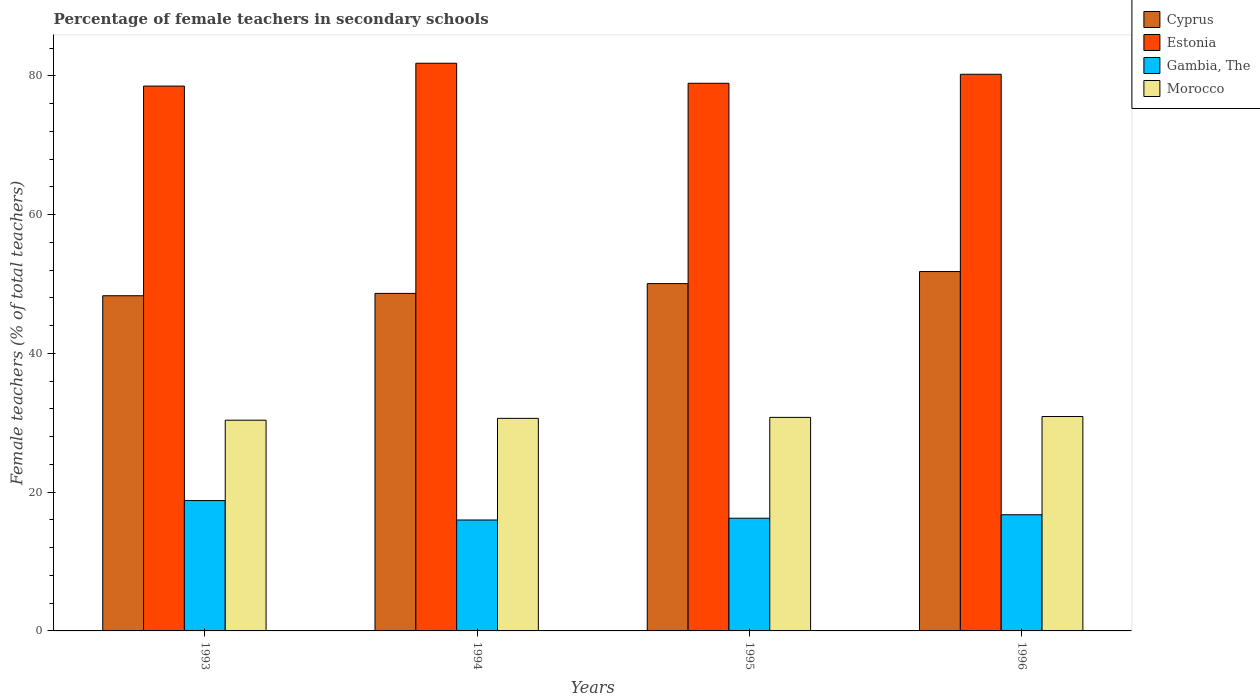How many different coloured bars are there?
Keep it short and to the point. 4. Are the number of bars per tick equal to the number of legend labels?
Your answer should be compact. Yes. Are the number of bars on each tick of the X-axis equal?
Keep it short and to the point. Yes. What is the label of the 4th group of bars from the left?
Keep it short and to the point. 1996. What is the percentage of female teachers in Cyprus in 1993?
Your answer should be compact. 48.3. Across all years, what is the maximum percentage of female teachers in Morocco?
Offer a terse response. 30.9. Across all years, what is the minimum percentage of female teachers in Morocco?
Give a very brief answer. 30.37. In which year was the percentage of female teachers in Estonia minimum?
Your answer should be compact. 1993. What is the total percentage of female teachers in Morocco in the graph?
Keep it short and to the point. 122.68. What is the difference between the percentage of female teachers in Estonia in 1994 and that in 1996?
Make the answer very short. 1.59. What is the difference between the percentage of female teachers in Estonia in 1993 and the percentage of female teachers in Gambia, The in 1994?
Ensure brevity in your answer.  62.54. What is the average percentage of female teachers in Cyprus per year?
Give a very brief answer. 49.7. In the year 1993, what is the difference between the percentage of female teachers in Gambia, The and percentage of female teachers in Morocco?
Ensure brevity in your answer.  -11.58. In how many years, is the percentage of female teachers in Cyprus greater than 4 %?
Ensure brevity in your answer.  4. What is the ratio of the percentage of female teachers in Estonia in 1995 to that in 1996?
Your answer should be very brief. 0.98. What is the difference between the highest and the second highest percentage of female teachers in Morocco?
Offer a terse response. 0.12. What is the difference between the highest and the lowest percentage of female teachers in Morocco?
Give a very brief answer. 0.53. In how many years, is the percentage of female teachers in Cyprus greater than the average percentage of female teachers in Cyprus taken over all years?
Give a very brief answer. 2. Is it the case that in every year, the sum of the percentage of female teachers in Estonia and percentage of female teachers in Gambia, The is greater than the sum of percentage of female teachers in Cyprus and percentage of female teachers in Morocco?
Provide a succinct answer. Yes. What does the 2nd bar from the left in 1993 represents?
Offer a very short reply. Estonia. What does the 3rd bar from the right in 1993 represents?
Give a very brief answer. Estonia. Is it the case that in every year, the sum of the percentage of female teachers in Morocco and percentage of female teachers in Estonia is greater than the percentage of female teachers in Gambia, The?
Ensure brevity in your answer.  Yes. How many bars are there?
Provide a succinct answer. 16. What is the difference between two consecutive major ticks on the Y-axis?
Your answer should be very brief. 20. Does the graph contain any zero values?
Offer a very short reply. No. Where does the legend appear in the graph?
Offer a very short reply. Top right. How many legend labels are there?
Your answer should be compact. 4. How are the legend labels stacked?
Your answer should be very brief. Vertical. What is the title of the graph?
Offer a very short reply. Percentage of female teachers in secondary schools. Does "Europe(all income levels)" appear as one of the legend labels in the graph?
Offer a very short reply. No. What is the label or title of the Y-axis?
Give a very brief answer. Female teachers (% of total teachers). What is the Female teachers (% of total teachers) in Cyprus in 1993?
Give a very brief answer. 48.3. What is the Female teachers (% of total teachers) in Estonia in 1993?
Your answer should be compact. 78.52. What is the Female teachers (% of total teachers) of Gambia, The in 1993?
Your response must be concise. 18.79. What is the Female teachers (% of total teachers) of Morocco in 1993?
Ensure brevity in your answer.  30.37. What is the Female teachers (% of total teachers) of Cyprus in 1994?
Make the answer very short. 48.64. What is the Female teachers (% of total teachers) in Estonia in 1994?
Offer a terse response. 81.81. What is the Female teachers (% of total teachers) of Gambia, The in 1994?
Provide a succinct answer. 15.99. What is the Female teachers (% of total teachers) of Morocco in 1994?
Keep it short and to the point. 30.63. What is the Female teachers (% of total teachers) in Cyprus in 1995?
Your response must be concise. 50.05. What is the Female teachers (% of total teachers) in Estonia in 1995?
Ensure brevity in your answer.  78.93. What is the Female teachers (% of total teachers) in Gambia, The in 1995?
Your answer should be very brief. 16.24. What is the Female teachers (% of total teachers) in Morocco in 1995?
Your response must be concise. 30.78. What is the Female teachers (% of total teachers) in Cyprus in 1996?
Your response must be concise. 51.79. What is the Female teachers (% of total teachers) in Estonia in 1996?
Provide a short and direct response. 80.22. What is the Female teachers (% of total teachers) of Gambia, The in 1996?
Offer a very short reply. 16.74. What is the Female teachers (% of total teachers) in Morocco in 1996?
Give a very brief answer. 30.9. Across all years, what is the maximum Female teachers (% of total teachers) of Cyprus?
Your answer should be compact. 51.79. Across all years, what is the maximum Female teachers (% of total teachers) in Estonia?
Ensure brevity in your answer.  81.81. Across all years, what is the maximum Female teachers (% of total teachers) of Gambia, The?
Provide a short and direct response. 18.79. Across all years, what is the maximum Female teachers (% of total teachers) of Morocco?
Keep it short and to the point. 30.9. Across all years, what is the minimum Female teachers (% of total teachers) of Cyprus?
Offer a terse response. 48.3. Across all years, what is the minimum Female teachers (% of total teachers) in Estonia?
Your answer should be compact. 78.52. Across all years, what is the minimum Female teachers (% of total teachers) in Gambia, The?
Give a very brief answer. 15.99. Across all years, what is the minimum Female teachers (% of total teachers) in Morocco?
Offer a very short reply. 30.37. What is the total Female teachers (% of total teachers) in Cyprus in the graph?
Give a very brief answer. 198.79. What is the total Female teachers (% of total teachers) of Estonia in the graph?
Your response must be concise. 319.48. What is the total Female teachers (% of total teachers) of Gambia, The in the graph?
Offer a terse response. 67.75. What is the total Female teachers (% of total teachers) in Morocco in the graph?
Offer a terse response. 122.68. What is the difference between the Female teachers (% of total teachers) of Cyprus in 1993 and that in 1994?
Ensure brevity in your answer.  -0.34. What is the difference between the Female teachers (% of total teachers) of Estonia in 1993 and that in 1994?
Your answer should be very brief. -3.29. What is the difference between the Female teachers (% of total teachers) of Gambia, The in 1993 and that in 1994?
Offer a very short reply. 2.8. What is the difference between the Female teachers (% of total teachers) of Morocco in 1993 and that in 1994?
Provide a succinct answer. -0.26. What is the difference between the Female teachers (% of total teachers) of Cyprus in 1993 and that in 1995?
Your answer should be compact. -1.75. What is the difference between the Female teachers (% of total teachers) of Estonia in 1993 and that in 1995?
Provide a short and direct response. -0.4. What is the difference between the Female teachers (% of total teachers) of Gambia, The in 1993 and that in 1995?
Ensure brevity in your answer.  2.54. What is the difference between the Female teachers (% of total teachers) in Morocco in 1993 and that in 1995?
Your response must be concise. -0.41. What is the difference between the Female teachers (% of total teachers) of Cyprus in 1993 and that in 1996?
Offer a terse response. -3.49. What is the difference between the Female teachers (% of total teachers) in Estonia in 1993 and that in 1996?
Keep it short and to the point. -1.7. What is the difference between the Female teachers (% of total teachers) of Gambia, The in 1993 and that in 1996?
Provide a short and direct response. 2.04. What is the difference between the Female teachers (% of total teachers) of Morocco in 1993 and that in 1996?
Your answer should be compact. -0.53. What is the difference between the Female teachers (% of total teachers) of Cyprus in 1994 and that in 1995?
Provide a succinct answer. -1.41. What is the difference between the Female teachers (% of total teachers) in Estonia in 1994 and that in 1995?
Keep it short and to the point. 2.88. What is the difference between the Female teachers (% of total teachers) of Gambia, The in 1994 and that in 1995?
Ensure brevity in your answer.  -0.25. What is the difference between the Female teachers (% of total teachers) of Morocco in 1994 and that in 1995?
Your answer should be very brief. -0.14. What is the difference between the Female teachers (% of total teachers) in Cyprus in 1994 and that in 1996?
Offer a very short reply. -3.15. What is the difference between the Female teachers (% of total teachers) of Estonia in 1994 and that in 1996?
Offer a terse response. 1.59. What is the difference between the Female teachers (% of total teachers) in Gambia, The in 1994 and that in 1996?
Offer a terse response. -0.76. What is the difference between the Female teachers (% of total teachers) of Morocco in 1994 and that in 1996?
Provide a succinct answer. -0.26. What is the difference between the Female teachers (% of total teachers) in Cyprus in 1995 and that in 1996?
Make the answer very short. -1.74. What is the difference between the Female teachers (% of total teachers) in Estonia in 1995 and that in 1996?
Offer a very short reply. -1.3. What is the difference between the Female teachers (% of total teachers) in Gambia, The in 1995 and that in 1996?
Your response must be concise. -0.5. What is the difference between the Female teachers (% of total teachers) of Morocco in 1995 and that in 1996?
Your response must be concise. -0.12. What is the difference between the Female teachers (% of total teachers) in Cyprus in 1993 and the Female teachers (% of total teachers) in Estonia in 1994?
Give a very brief answer. -33.5. What is the difference between the Female teachers (% of total teachers) of Cyprus in 1993 and the Female teachers (% of total teachers) of Gambia, The in 1994?
Your response must be concise. 32.32. What is the difference between the Female teachers (% of total teachers) in Cyprus in 1993 and the Female teachers (% of total teachers) in Morocco in 1994?
Your response must be concise. 17.67. What is the difference between the Female teachers (% of total teachers) in Estonia in 1993 and the Female teachers (% of total teachers) in Gambia, The in 1994?
Ensure brevity in your answer.  62.54. What is the difference between the Female teachers (% of total teachers) in Estonia in 1993 and the Female teachers (% of total teachers) in Morocco in 1994?
Your response must be concise. 47.89. What is the difference between the Female teachers (% of total teachers) of Gambia, The in 1993 and the Female teachers (% of total teachers) of Morocco in 1994?
Your answer should be very brief. -11.85. What is the difference between the Female teachers (% of total teachers) in Cyprus in 1993 and the Female teachers (% of total teachers) in Estonia in 1995?
Provide a short and direct response. -30.62. What is the difference between the Female teachers (% of total teachers) in Cyprus in 1993 and the Female teachers (% of total teachers) in Gambia, The in 1995?
Provide a short and direct response. 32.06. What is the difference between the Female teachers (% of total teachers) of Cyprus in 1993 and the Female teachers (% of total teachers) of Morocco in 1995?
Offer a terse response. 17.53. What is the difference between the Female teachers (% of total teachers) of Estonia in 1993 and the Female teachers (% of total teachers) of Gambia, The in 1995?
Your answer should be compact. 62.28. What is the difference between the Female teachers (% of total teachers) of Estonia in 1993 and the Female teachers (% of total teachers) of Morocco in 1995?
Provide a short and direct response. 47.75. What is the difference between the Female teachers (% of total teachers) in Gambia, The in 1993 and the Female teachers (% of total teachers) in Morocco in 1995?
Provide a short and direct response. -11.99. What is the difference between the Female teachers (% of total teachers) in Cyprus in 1993 and the Female teachers (% of total teachers) in Estonia in 1996?
Provide a succinct answer. -31.92. What is the difference between the Female teachers (% of total teachers) in Cyprus in 1993 and the Female teachers (% of total teachers) in Gambia, The in 1996?
Your answer should be very brief. 31.56. What is the difference between the Female teachers (% of total teachers) in Cyprus in 1993 and the Female teachers (% of total teachers) in Morocco in 1996?
Provide a succinct answer. 17.41. What is the difference between the Female teachers (% of total teachers) in Estonia in 1993 and the Female teachers (% of total teachers) in Gambia, The in 1996?
Provide a succinct answer. 61.78. What is the difference between the Female teachers (% of total teachers) of Estonia in 1993 and the Female teachers (% of total teachers) of Morocco in 1996?
Offer a very short reply. 47.62. What is the difference between the Female teachers (% of total teachers) of Gambia, The in 1993 and the Female teachers (% of total teachers) of Morocco in 1996?
Provide a succinct answer. -12.11. What is the difference between the Female teachers (% of total teachers) of Cyprus in 1994 and the Female teachers (% of total teachers) of Estonia in 1995?
Make the answer very short. -30.28. What is the difference between the Female teachers (% of total teachers) in Cyprus in 1994 and the Female teachers (% of total teachers) in Gambia, The in 1995?
Give a very brief answer. 32.4. What is the difference between the Female teachers (% of total teachers) of Cyprus in 1994 and the Female teachers (% of total teachers) of Morocco in 1995?
Keep it short and to the point. 17.87. What is the difference between the Female teachers (% of total teachers) of Estonia in 1994 and the Female teachers (% of total teachers) of Gambia, The in 1995?
Offer a very short reply. 65.57. What is the difference between the Female teachers (% of total teachers) of Estonia in 1994 and the Female teachers (% of total teachers) of Morocco in 1995?
Provide a succinct answer. 51.03. What is the difference between the Female teachers (% of total teachers) in Gambia, The in 1994 and the Female teachers (% of total teachers) in Morocco in 1995?
Provide a short and direct response. -14.79. What is the difference between the Female teachers (% of total teachers) of Cyprus in 1994 and the Female teachers (% of total teachers) of Estonia in 1996?
Your answer should be very brief. -31.58. What is the difference between the Female teachers (% of total teachers) in Cyprus in 1994 and the Female teachers (% of total teachers) in Gambia, The in 1996?
Give a very brief answer. 31.9. What is the difference between the Female teachers (% of total teachers) of Cyprus in 1994 and the Female teachers (% of total teachers) of Morocco in 1996?
Make the answer very short. 17.74. What is the difference between the Female teachers (% of total teachers) of Estonia in 1994 and the Female teachers (% of total teachers) of Gambia, The in 1996?
Offer a very short reply. 65.07. What is the difference between the Female teachers (% of total teachers) of Estonia in 1994 and the Female teachers (% of total teachers) of Morocco in 1996?
Offer a very short reply. 50.91. What is the difference between the Female teachers (% of total teachers) of Gambia, The in 1994 and the Female teachers (% of total teachers) of Morocco in 1996?
Your answer should be compact. -14.91. What is the difference between the Female teachers (% of total teachers) of Cyprus in 1995 and the Female teachers (% of total teachers) of Estonia in 1996?
Keep it short and to the point. -30.17. What is the difference between the Female teachers (% of total teachers) of Cyprus in 1995 and the Female teachers (% of total teachers) of Gambia, The in 1996?
Your answer should be compact. 33.31. What is the difference between the Female teachers (% of total teachers) in Cyprus in 1995 and the Female teachers (% of total teachers) in Morocco in 1996?
Ensure brevity in your answer.  19.16. What is the difference between the Female teachers (% of total teachers) in Estonia in 1995 and the Female teachers (% of total teachers) in Gambia, The in 1996?
Offer a terse response. 62.18. What is the difference between the Female teachers (% of total teachers) of Estonia in 1995 and the Female teachers (% of total teachers) of Morocco in 1996?
Your answer should be very brief. 48.03. What is the difference between the Female teachers (% of total teachers) in Gambia, The in 1995 and the Female teachers (% of total teachers) in Morocco in 1996?
Offer a terse response. -14.66. What is the average Female teachers (% of total teachers) of Cyprus per year?
Offer a terse response. 49.7. What is the average Female teachers (% of total teachers) in Estonia per year?
Provide a succinct answer. 79.87. What is the average Female teachers (% of total teachers) in Gambia, The per year?
Your answer should be compact. 16.94. What is the average Female teachers (% of total teachers) in Morocco per year?
Offer a very short reply. 30.67. In the year 1993, what is the difference between the Female teachers (% of total teachers) in Cyprus and Female teachers (% of total teachers) in Estonia?
Offer a terse response. -30.22. In the year 1993, what is the difference between the Female teachers (% of total teachers) of Cyprus and Female teachers (% of total teachers) of Gambia, The?
Your response must be concise. 29.52. In the year 1993, what is the difference between the Female teachers (% of total teachers) of Cyprus and Female teachers (% of total teachers) of Morocco?
Your answer should be compact. 17.93. In the year 1993, what is the difference between the Female teachers (% of total teachers) in Estonia and Female teachers (% of total teachers) in Gambia, The?
Your response must be concise. 59.74. In the year 1993, what is the difference between the Female teachers (% of total teachers) in Estonia and Female teachers (% of total teachers) in Morocco?
Offer a very short reply. 48.15. In the year 1993, what is the difference between the Female teachers (% of total teachers) of Gambia, The and Female teachers (% of total teachers) of Morocco?
Your response must be concise. -11.58. In the year 1994, what is the difference between the Female teachers (% of total teachers) in Cyprus and Female teachers (% of total teachers) in Estonia?
Your answer should be compact. -33.17. In the year 1994, what is the difference between the Female teachers (% of total teachers) of Cyprus and Female teachers (% of total teachers) of Gambia, The?
Ensure brevity in your answer.  32.66. In the year 1994, what is the difference between the Female teachers (% of total teachers) in Cyprus and Female teachers (% of total teachers) in Morocco?
Keep it short and to the point. 18.01. In the year 1994, what is the difference between the Female teachers (% of total teachers) in Estonia and Female teachers (% of total teachers) in Gambia, The?
Offer a very short reply. 65.82. In the year 1994, what is the difference between the Female teachers (% of total teachers) in Estonia and Female teachers (% of total teachers) in Morocco?
Offer a very short reply. 51.18. In the year 1994, what is the difference between the Female teachers (% of total teachers) in Gambia, The and Female teachers (% of total teachers) in Morocco?
Your answer should be very brief. -14.65. In the year 1995, what is the difference between the Female teachers (% of total teachers) of Cyprus and Female teachers (% of total teachers) of Estonia?
Your response must be concise. -28.87. In the year 1995, what is the difference between the Female teachers (% of total teachers) of Cyprus and Female teachers (% of total teachers) of Gambia, The?
Your response must be concise. 33.81. In the year 1995, what is the difference between the Female teachers (% of total teachers) of Cyprus and Female teachers (% of total teachers) of Morocco?
Offer a very short reply. 19.28. In the year 1995, what is the difference between the Female teachers (% of total teachers) of Estonia and Female teachers (% of total teachers) of Gambia, The?
Your response must be concise. 62.68. In the year 1995, what is the difference between the Female teachers (% of total teachers) of Estonia and Female teachers (% of total teachers) of Morocco?
Offer a terse response. 48.15. In the year 1995, what is the difference between the Female teachers (% of total teachers) of Gambia, The and Female teachers (% of total teachers) of Morocco?
Your answer should be very brief. -14.53. In the year 1996, what is the difference between the Female teachers (% of total teachers) in Cyprus and Female teachers (% of total teachers) in Estonia?
Offer a terse response. -28.43. In the year 1996, what is the difference between the Female teachers (% of total teachers) in Cyprus and Female teachers (% of total teachers) in Gambia, The?
Offer a terse response. 35.05. In the year 1996, what is the difference between the Female teachers (% of total teachers) of Cyprus and Female teachers (% of total teachers) of Morocco?
Your answer should be compact. 20.89. In the year 1996, what is the difference between the Female teachers (% of total teachers) in Estonia and Female teachers (% of total teachers) in Gambia, The?
Offer a very short reply. 63.48. In the year 1996, what is the difference between the Female teachers (% of total teachers) in Estonia and Female teachers (% of total teachers) in Morocco?
Offer a terse response. 49.32. In the year 1996, what is the difference between the Female teachers (% of total teachers) in Gambia, The and Female teachers (% of total teachers) in Morocco?
Keep it short and to the point. -14.16. What is the ratio of the Female teachers (% of total teachers) in Estonia in 1993 to that in 1994?
Provide a short and direct response. 0.96. What is the ratio of the Female teachers (% of total teachers) in Gambia, The in 1993 to that in 1994?
Keep it short and to the point. 1.18. What is the ratio of the Female teachers (% of total teachers) in Morocco in 1993 to that in 1994?
Provide a succinct answer. 0.99. What is the ratio of the Female teachers (% of total teachers) in Cyprus in 1993 to that in 1995?
Ensure brevity in your answer.  0.96. What is the ratio of the Female teachers (% of total teachers) in Gambia, The in 1993 to that in 1995?
Ensure brevity in your answer.  1.16. What is the ratio of the Female teachers (% of total teachers) of Cyprus in 1993 to that in 1996?
Make the answer very short. 0.93. What is the ratio of the Female teachers (% of total teachers) in Estonia in 1993 to that in 1996?
Offer a terse response. 0.98. What is the ratio of the Female teachers (% of total teachers) in Gambia, The in 1993 to that in 1996?
Your answer should be very brief. 1.12. What is the ratio of the Female teachers (% of total teachers) in Morocco in 1993 to that in 1996?
Keep it short and to the point. 0.98. What is the ratio of the Female teachers (% of total teachers) in Cyprus in 1994 to that in 1995?
Your answer should be very brief. 0.97. What is the ratio of the Female teachers (% of total teachers) of Estonia in 1994 to that in 1995?
Your response must be concise. 1.04. What is the ratio of the Female teachers (% of total teachers) of Gambia, The in 1994 to that in 1995?
Your response must be concise. 0.98. What is the ratio of the Female teachers (% of total teachers) in Cyprus in 1994 to that in 1996?
Offer a very short reply. 0.94. What is the ratio of the Female teachers (% of total teachers) of Estonia in 1994 to that in 1996?
Offer a terse response. 1.02. What is the ratio of the Female teachers (% of total teachers) of Gambia, The in 1994 to that in 1996?
Your answer should be very brief. 0.95. What is the ratio of the Female teachers (% of total teachers) in Morocco in 1994 to that in 1996?
Ensure brevity in your answer.  0.99. What is the ratio of the Female teachers (% of total teachers) in Cyprus in 1995 to that in 1996?
Your answer should be compact. 0.97. What is the ratio of the Female teachers (% of total teachers) in Estonia in 1995 to that in 1996?
Ensure brevity in your answer.  0.98. What is the ratio of the Female teachers (% of total teachers) of Gambia, The in 1995 to that in 1996?
Keep it short and to the point. 0.97. What is the ratio of the Female teachers (% of total teachers) in Morocco in 1995 to that in 1996?
Keep it short and to the point. 1. What is the difference between the highest and the second highest Female teachers (% of total teachers) of Cyprus?
Offer a very short reply. 1.74. What is the difference between the highest and the second highest Female teachers (% of total teachers) in Estonia?
Your response must be concise. 1.59. What is the difference between the highest and the second highest Female teachers (% of total teachers) in Gambia, The?
Ensure brevity in your answer.  2.04. What is the difference between the highest and the second highest Female teachers (% of total teachers) in Morocco?
Your answer should be compact. 0.12. What is the difference between the highest and the lowest Female teachers (% of total teachers) in Cyprus?
Your response must be concise. 3.49. What is the difference between the highest and the lowest Female teachers (% of total teachers) in Estonia?
Ensure brevity in your answer.  3.29. What is the difference between the highest and the lowest Female teachers (% of total teachers) of Gambia, The?
Ensure brevity in your answer.  2.8. What is the difference between the highest and the lowest Female teachers (% of total teachers) of Morocco?
Offer a very short reply. 0.53. 